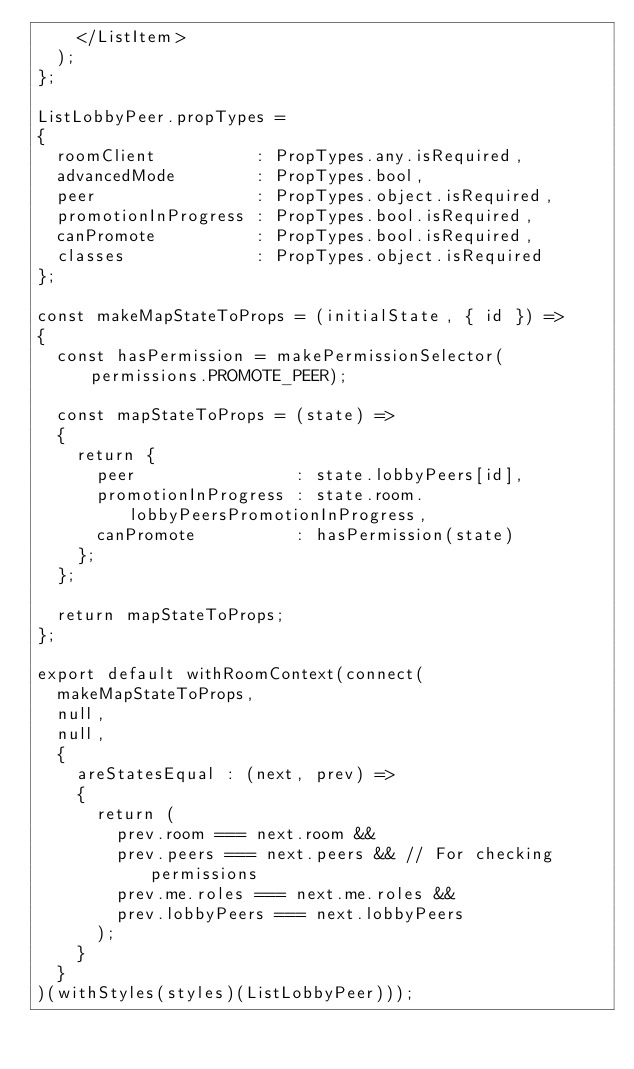Convert code to text. <code><loc_0><loc_0><loc_500><loc_500><_JavaScript_>		</ListItem>
	);
};

ListLobbyPeer.propTypes =
{
	roomClient          : PropTypes.any.isRequired,
	advancedMode        : PropTypes.bool,
	peer                : PropTypes.object.isRequired,
	promotionInProgress : PropTypes.bool.isRequired,
	canPromote          : PropTypes.bool.isRequired,
	classes             : PropTypes.object.isRequired
};

const makeMapStateToProps = (initialState, { id }) =>
{
	const hasPermission = makePermissionSelector(permissions.PROMOTE_PEER);

	const mapStateToProps = (state) =>
	{
		return {
			peer                : state.lobbyPeers[id],
			promotionInProgress : state.room.lobbyPeersPromotionInProgress,
			canPromote          : hasPermission(state)
		};
	};

	return mapStateToProps;
};

export default withRoomContext(connect(
	makeMapStateToProps,
	null,
	null,
	{
		areStatesEqual : (next, prev) =>
		{
			return (
				prev.room === next.room &&
				prev.peers === next.peers && // For checking permissions
				prev.me.roles === next.me.roles &&
				prev.lobbyPeers === next.lobbyPeers
			);
		}
	}
)(withStyles(styles)(ListLobbyPeer)));</code> 